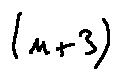<formula> <loc_0><loc_0><loc_500><loc_500>( n + 3 )</formula> 